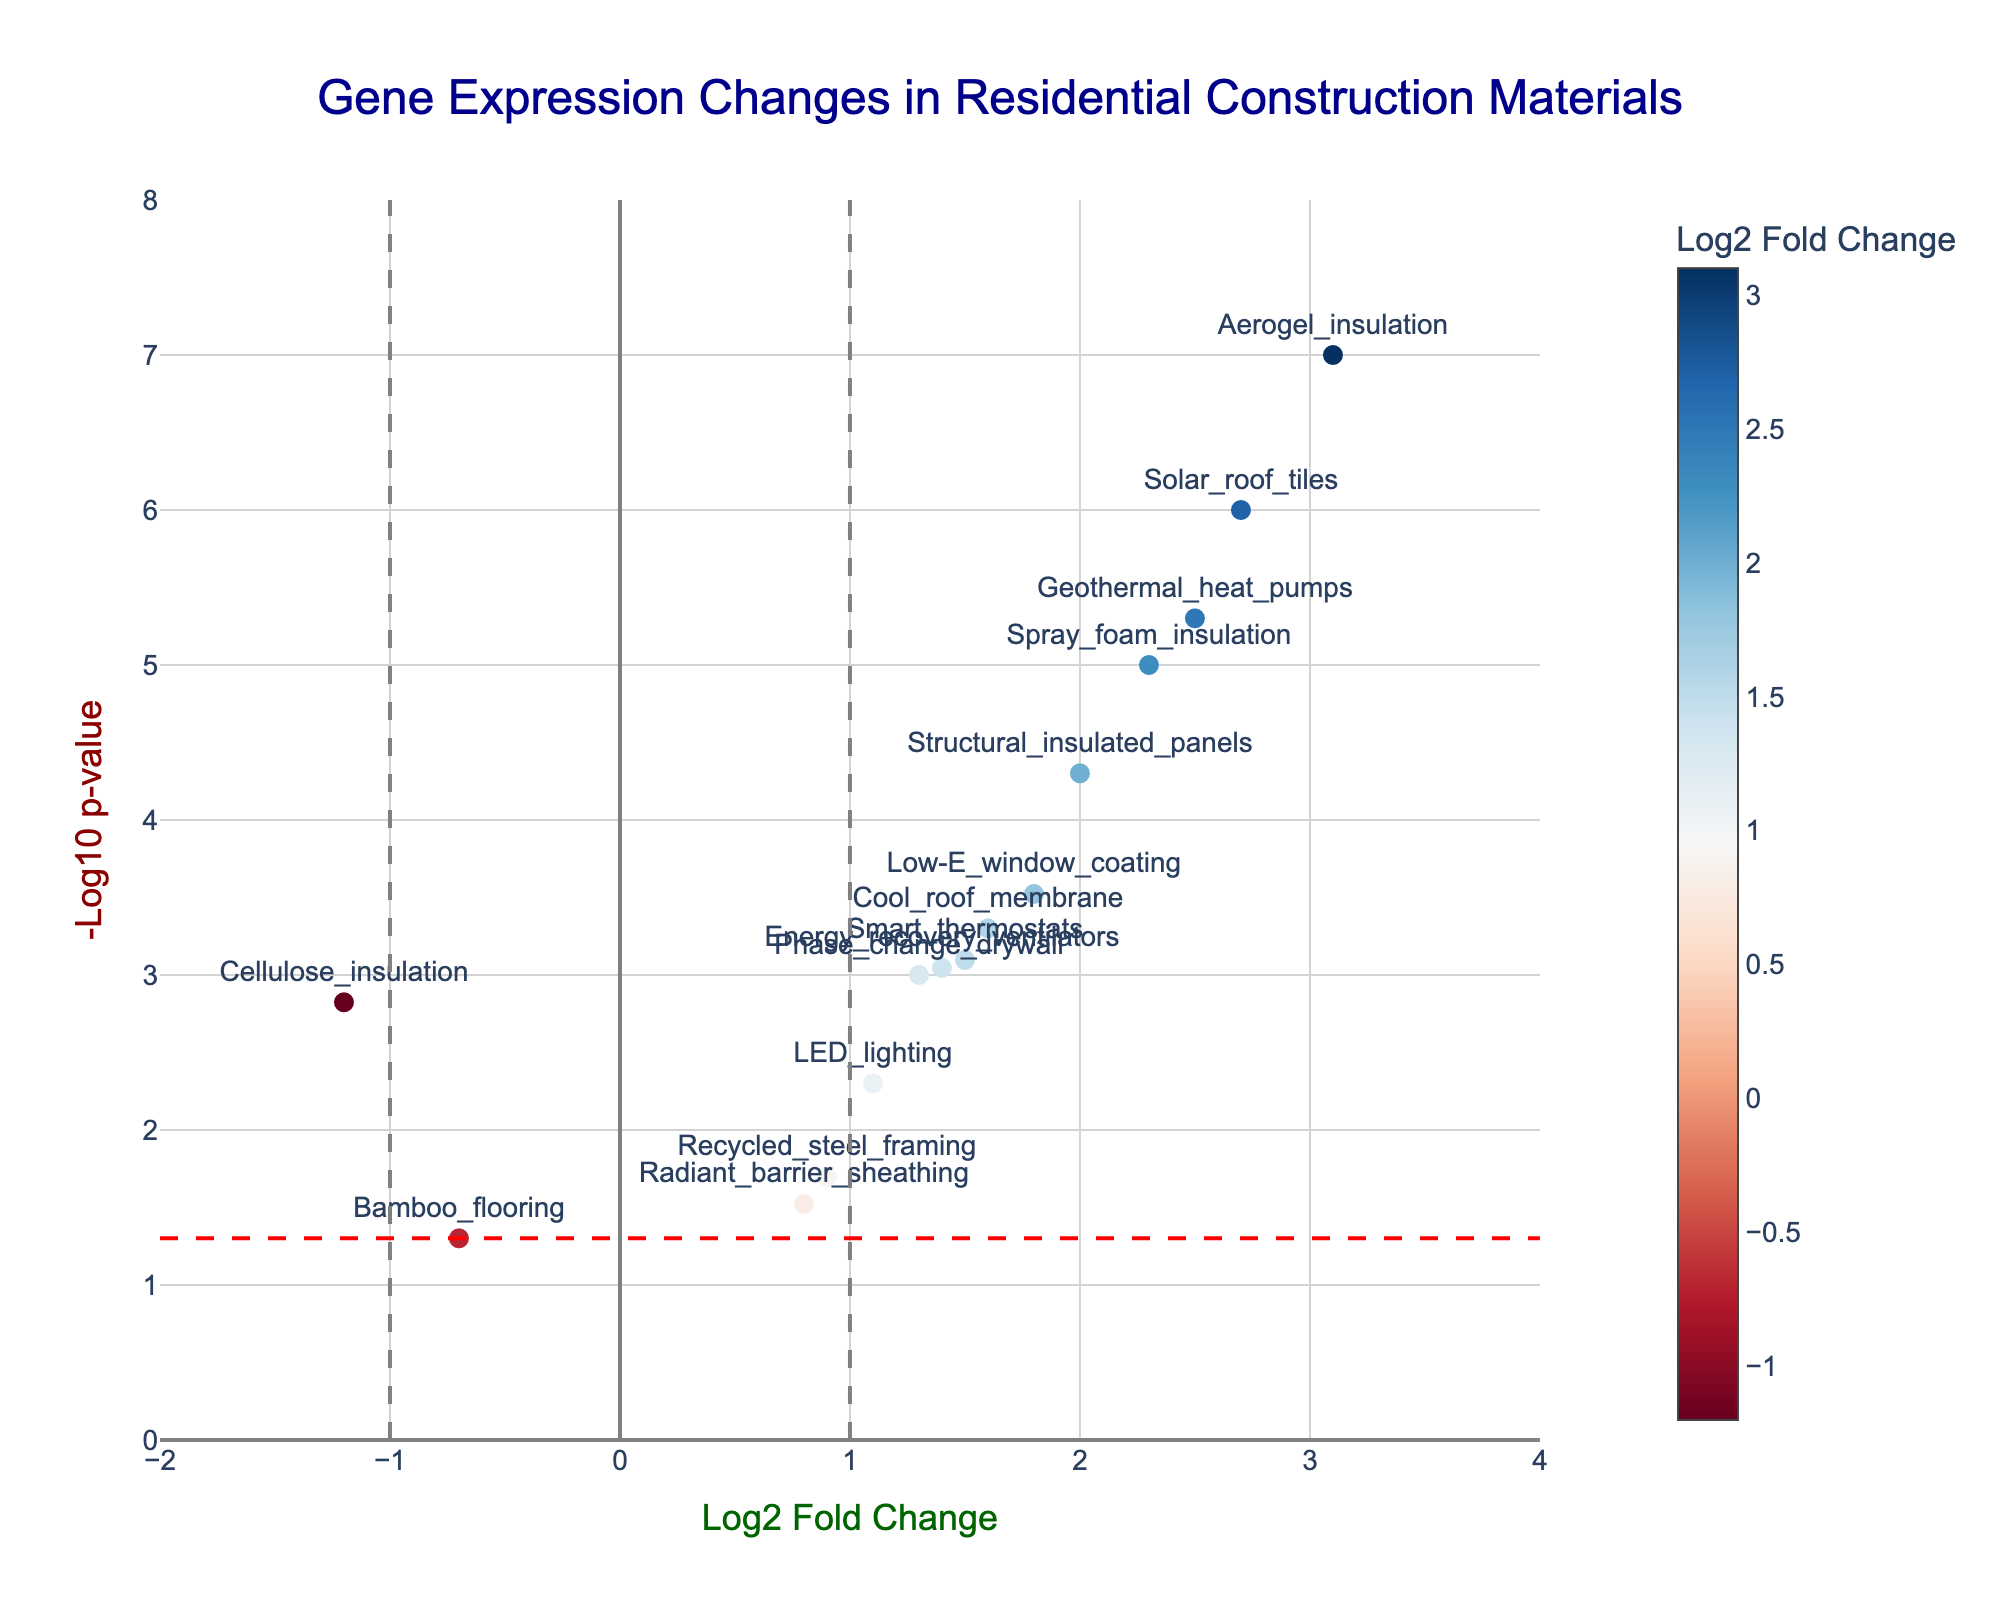Which construction material has the most significant improvement in home energy efficiency? The significance is indicated by the smallest p-value, which translates to the highest -log10(p-value). Thus, Solar_roof_tiles has the highest -log10(p-value), making it the most significant.
Answer: Solar_roof_tiles Which material shows a substantial decrease in home energy efficiency? Materials with a log2_fold_change less than -1 represent a substantial decrease. Cellulose_insulation has a log2_fold_change of -1.2, which fits this criteria.
Answer: Cellulose_insulation How many materials have p-values less than 0.05? A p-value less than 0.05 translates to a -log10(p-value) greater than -log10(0.05), which is roughly 1.3. Counting the points above this threshold in the plot gives the number of significant materials.
Answer: 12 Which material is closest to the threshold of being significantly different in terms of p-value? Bamboo_flooring has the highest p-value among the materials, just reaching the significance threshold with a p-value of 0.05.
Answer: Bamboo_flooring What is the log2 fold change of Spray_foam_insulation? Observing the x-axis position for Spray_foam_insulation on the plot shows a log2 fold change value.
Answer: 2.3 Which materials have a log2 fold change greater than 2? Observing the points on the plot with log2 fold_change values greater than 2 identifies these materials.
Answer: Spray_foam_insulation, Solar_roof_tiles, Geothermal_heat_pumps, Aerogel_insulation, Structural_insulated_panels What material has the second highest positive log2 fold change? Ranking the materials by their log2 fold change, Aerogel_insulation is highest, followed by Solar_roof_tiles.
Answer: Solar_roof_tiles What is the color scheme used to indicate the fold change in the plot? The color scheme is based on a gradient scale, often indicating magnitude changes with a blue-to-red transition, where red tones generally represent higher log2 fold changes and blue tones denote lower ones.
Answer: Red-to-blue gradient Which material lies on the intersection of the vertical and horizontal significance lines? Intersection points are around log2 fold change of ±1 and -log10(p-value) of around 1.3.
Answer: None Among the significant results, which material has the lowest log2 fold change? Among the points above the threshold line, the point with the lowest x-value indicates the smallest log2 fold change.
Answer: Cellulose_insulation 